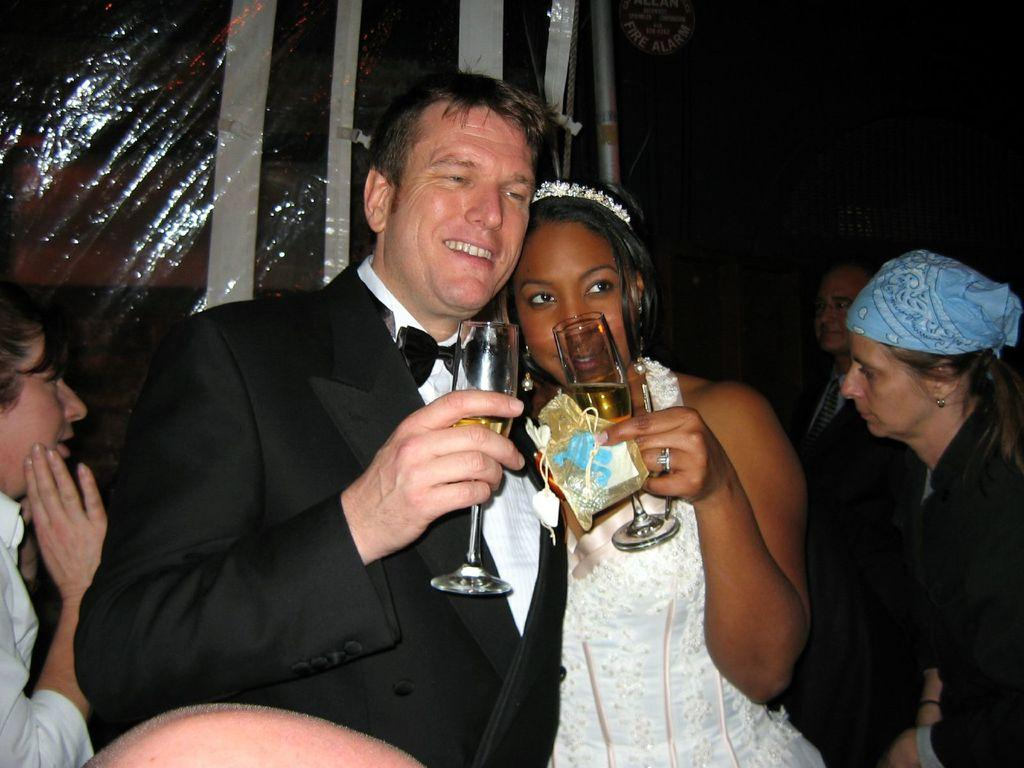What are the men and women in the image holding? The men and women in the image are holding glasses. What is the facial expression of the men and women in the image? The men and women in the image are smiling. Can you describe the other people in the image? There are other people in the image, but their specific actions or appearances are not mentioned in the provided facts. What can be seen in the background of the image? There is a sheet visible in the background of the image. What type of tooth is visible in the image? There is no tooth visible in the image. What class are the men and women attending in the image? The provided facts do not mention any class or educational setting, so it cannot be determined from the image. 